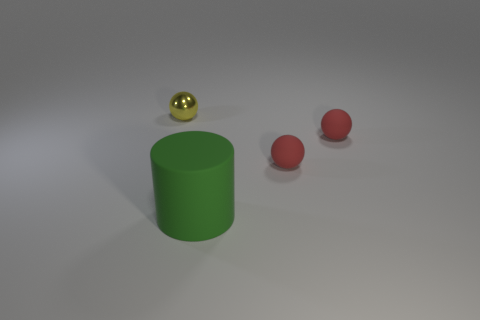What number of other things are there of the same material as the green cylinder
Provide a short and direct response. 2. Is the color of the small metal ball the same as the big rubber cylinder?
Your answer should be compact. No. How many things are tiny spheres on the right side of the small shiny ball or red things?
Offer a terse response. 2. There is a large green object; is it the same shape as the tiny thing to the left of the large cylinder?
Provide a succinct answer. No. What number of objects are either matte objects that are on the right side of the large green thing or small things right of the metallic object?
Give a very brief answer. 2. Is the number of large cylinders that are left of the small yellow sphere less than the number of spheres?
Ensure brevity in your answer.  Yes. Are the big green object and the small ball that is on the left side of the green matte cylinder made of the same material?
Offer a very short reply. No. What material is the green object?
Make the answer very short. Rubber. There is a cylinder; is it the same color as the object that is left of the cylinder?
Provide a short and direct response. No. Are there any other things that are the same shape as the green thing?
Offer a terse response. No. 